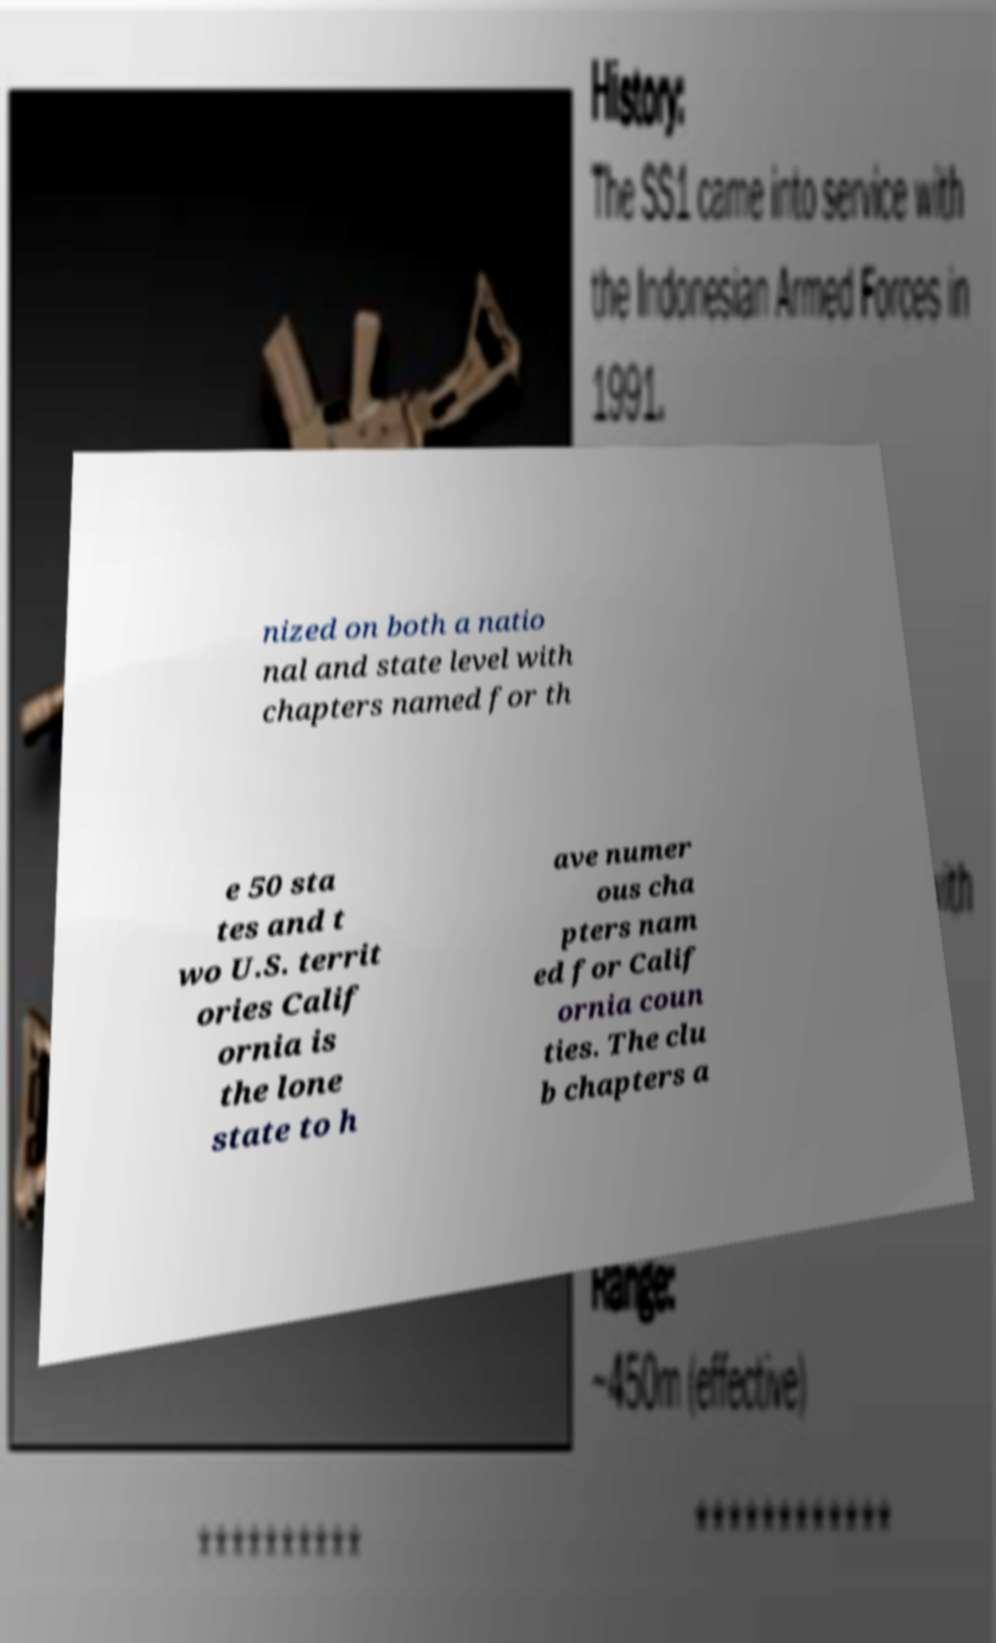What messages or text are displayed in this image? I need them in a readable, typed format. nized on both a natio nal and state level with chapters named for th e 50 sta tes and t wo U.S. territ ories Calif ornia is the lone state to h ave numer ous cha pters nam ed for Calif ornia coun ties. The clu b chapters a 